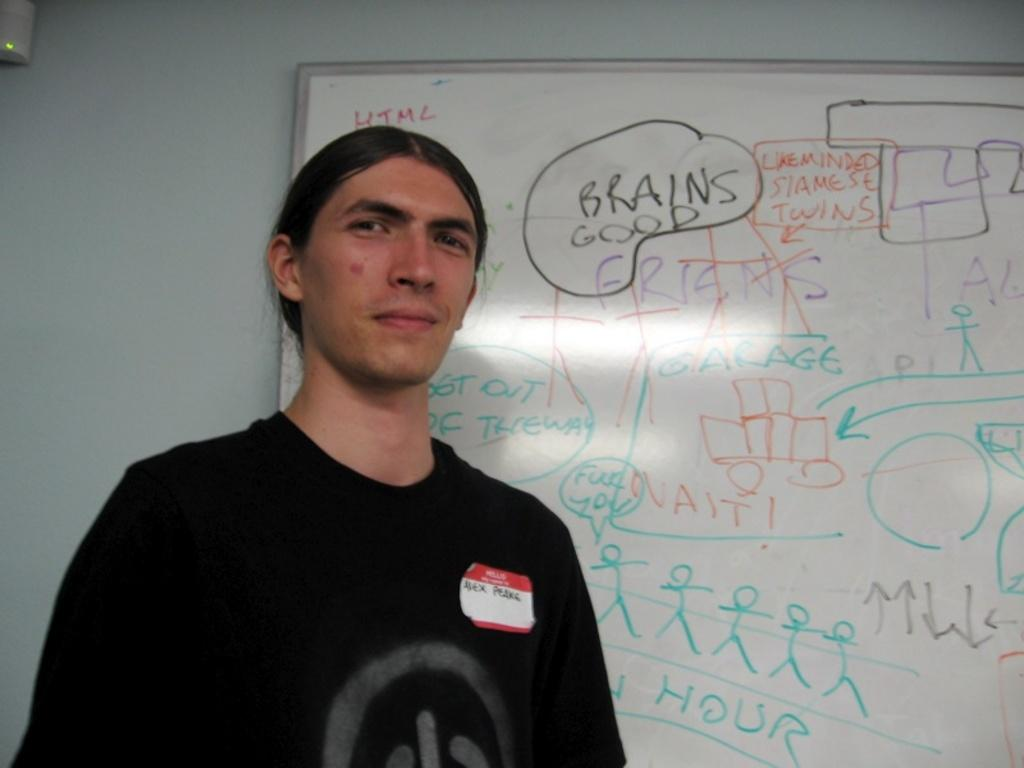<image>
Write a terse but informative summary of the picture. A man with a name tag identifying him as Alex stands in front of a white board. 